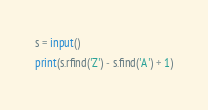<code> <loc_0><loc_0><loc_500><loc_500><_Python_>s = input()
print(s.rfind('Z') - s.find('A') + 1)</code> 